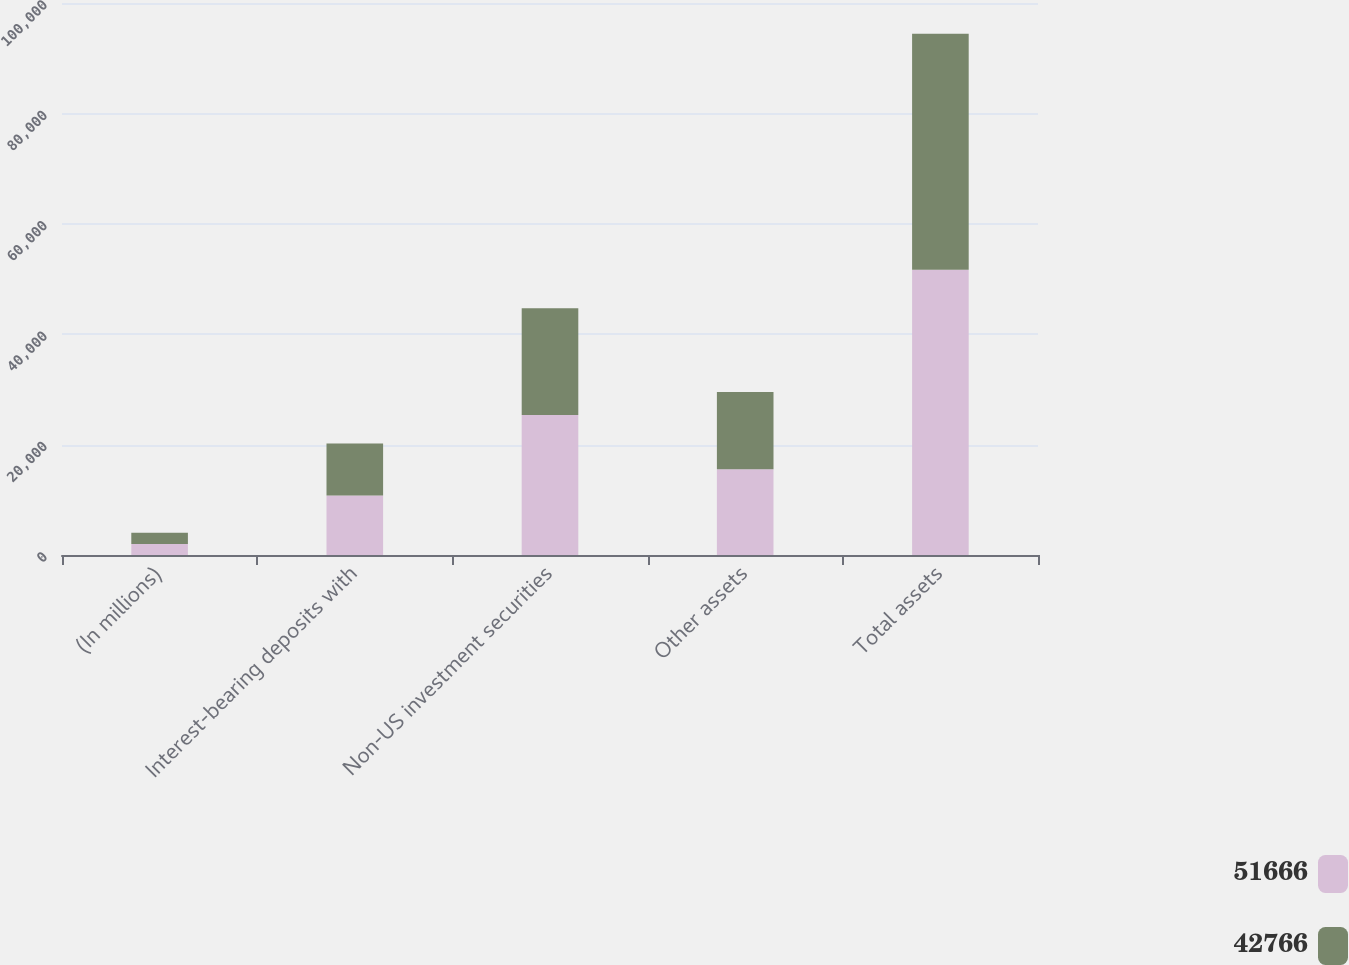Convert chart to OTSL. <chart><loc_0><loc_0><loc_500><loc_500><stacked_bar_chart><ecel><fcel>(In millions)<fcel>Interest-bearing deposits with<fcel>Non-US investment securities<fcel>Other assets<fcel>Total assets<nl><fcel>51666<fcel>2011<fcel>10772<fcel>25376<fcel>15518<fcel>51666<nl><fcel>42766<fcel>2010<fcel>9443<fcel>19329<fcel>13994<fcel>42766<nl></chart> 